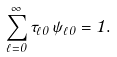Convert formula to latex. <formula><loc_0><loc_0><loc_500><loc_500>\sum _ { \ell = 0 } ^ { \infty } \tau _ { \ell 0 } \, \psi _ { \ell 0 } = 1 .</formula> 